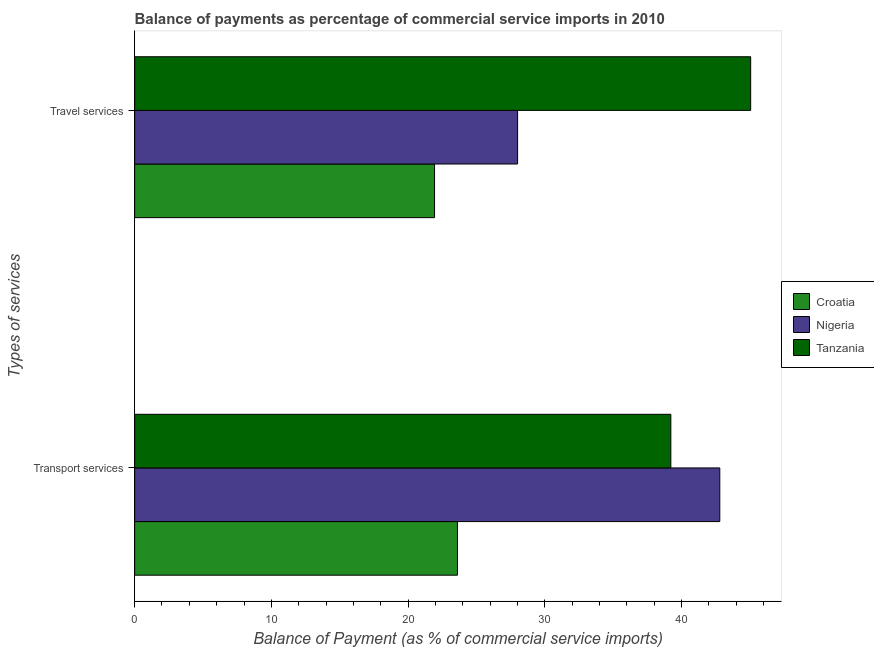How many different coloured bars are there?
Keep it short and to the point. 3. How many groups of bars are there?
Your answer should be very brief. 2. Are the number of bars per tick equal to the number of legend labels?
Your answer should be compact. Yes. How many bars are there on the 1st tick from the top?
Provide a short and direct response. 3. What is the label of the 2nd group of bars from the top?
Ensure brevity in your answer.  Transport services. What is the balance of payments of travel services in Nigeria?
Your answer should be very brief. 28.02. Across all countries, what is the maximum balance of payments of travel services?
Your answer should be compact. 45.07. Across all countries, what is the minimum balance of payments of travel services?
Your answer should be very brief. 21.94. In which country was the balance of payments of travel services maximum?
Your answer should be compact. Tanzania. In which country was the balance of payments of transport services minimum?
Offer a terse response. Croatia. What is the total balance of payments of travel services in the graph?
Your answer should be compact. 95.03. What is the difference between the balance of payments of travel services in Nigeria and that in Croatia?
Ensure brevity in your answer.  6.08. What is the difference between the balance of payments of transport services in Croatia and the balance of payments of travel services in Tanzania?
Provide a short and direct response. -21.45. What is the average balance of payments of travel services per country?
Provide a short and direct response. 31.68. What is the difference between the balance of payments of transport services and balance of payments of travel services in Nigeria?
Offer a very short reply. 14.79. What is the ratio of the balance of payments of travel services in Croatia to that in Tanzania?
Offer a terse response. 0.49. What does the 3rd bar from the top in Transport services represents?
Give a very brief answer. Croatia. What does the 3rd bar from the bottom in Travel services represents?
Give a very brief answer. Tanzania. Are all the bars in the graph horizontal?
Your answer should be compact. Yes. How many countries are there in the graph?
Provide a succinct answer. 3. Does the graph contain grids?
Your answer should be compact. No. How are the legend labels stacked?
Keep it short and to the point. Vertical. What is the title of the graph?
Provide a short and direct response. Balance of payments as percentage of commercial service imports in 2010. Does "Iceland" appear as one of the legend labels in the graph?
Your answer should be very brief. No. What is the label or title of the X-axis?
Your response must be concise. Balance of Payment (as % of commercial service imports). What is the label or title of the Y-axis?
Offer a very short reply. Types of services. What is the Balance of Payment (as % of commercial service imports) of Croatia in Transport services?
Provide a short and direct response. 23.62. What is the Balance of Payment (as % of commercial service imports) in Nigeria in Transport services?
Offer a terse response. 42.81. What is the Balance of Payment (as % of commercial service imports) of Tanzania in Transport services?
Keep it short and to the point. 39.23. What is the Balance of Payment (as % of commercial service imports) in Croatia in Travel services?
Offer a very short reply. 21.94. What is the Balance of Payment (as % of commercial service imports) of Nigeria in Travel services?
Offer a very short reply. 28.02. What is the Balance of Payment (as % of commercial service imports) in Tanzania in Travel services?
Offer a terse response. 45.07. Across all Types of services, what is the maximum Balance of Payment (as % of commercial service imports) in Croatia?
Give a very brief answer. 23.62. Across all Types of services, what is the maximum Balance of Payment (as % of commercial service imports) of Nigeria?
Ensure brevity in your answer.  42.81. Across all Types of services, what is the maximum Balance of Payment (as % of commercial service imports) in Tanzania?
Ensure brevity in your answer.  45.07. Across all Types of services, what is the minimum Balance of Payment (as % of commercial service imports) of Croatia?
Your answer should be very brief. 21.94. Across all Types of services, what is the minimum Balance of Payment (as % of commercial service imports) in Nigeria?
Make the answer very short. 28.02. Across all Types of services, what is the minimum Balance of Payment (as % of commercial service imports) of Tanzania?
Offer a very short reply. 39.23. What is the total Balance of Payment (as % of commercial service imports) of Croatia in the graph?
Provide a short and direct response. 45.56. What is the total Balance of Payment (as % of commercial service imports) of Nigeria in the graph?
Give a very brief answer. 70.83. What is the total Balance of Payment (as % of commercial service imports) of Tanzania in the graph?
Your answer should be compact. 84.3. What is the difference between the Balance of Payment (as % of commercial service imports) of Croatia in Transport services and that in Travel services?
Give a very brief answer. 1.68. What is the difference between the Balance of Payment (as % of commercial service imports) in Nigeria in Transport services and that in Travel services?
Keep it short and to the point. 14.79. What is the difference between the Balance of Payment (as % of commercial service imports) in Tanzania in Transport services and that in Travel services?
Keep it short and to the point. -5.84. What is the difference between the Balance of Payment (as % of commercial service imports) in Croatia in Transport services and the Balance of Payment (as % of commercial service imports) in Nigeria in Travel services?
Your answer should be very brief. -4.4. What is the difference between the Balance of Payment (as % of commercial service imports) of Croatia in Transport services and the Balance of Payment (as % of commercial service imports) of Tanzania in Travel services?
Your answer should be very brief. -21.45. What is the difference between the Balance of Payment (as % of commercial service imports) of Nigeria in Transport services and the Balance of Payment (as % of commercial service imports) of Tanzania in Travel services?
Your answer should be compact. -2.26. What is the average Balance of Payment (as % of commercial service imports) of Croatia per Types of services?
Give a very brief answer. 22.78. What is the average Balance of Payment (as % of commercial service imports) in Nigeria per Types of services?
Provide a succinct answer. 35.41. What is the average Balance of Payment (as % of commercial service imports) of Tanzania per Types of services?
Ensure brevity in your answer.  42.15. What is the difference between the Balance of Payment (as % of commercial service imports) in Croatia and Balance of Payment (as % of commercial service imports) in Nigeria in Transport services?
Your answer should be very brief. -19.19. What is the difference between the Balance of Payment (as % of commercial service imports) in Croatia and Balance of Payment (as % of commercial service imports) in Tanzania in Transport services?
Your response must be concise. -15.61. What is the difference between the Balance of Payment (as % of commercial service imports) of Nigeria and Balance of Payment (as % of commercial service imports) of Tanzania in Transport services?
Your answer should be compact. 3.58. What is the difference between the Balance of Payment (as % of commercial service imports) in Croatia and Balance of Payment (as % of commercial service imports) in Nigeria in Travel services?
Your answer should be very brief. -6.08. What is the difference between the Balance of Payment (as % of commercial service imports) of Croatia and Balance of Payment (as % of commercial service imports) of Tanzania in Travel services?
Give a very brief answer. -23.13. What is the difference between the Balance of Payment (as % of commercial service imports) in Nigeria and Balance of Payment (as % of commercial service imports) in Tanzania in Travel services?
Make the answer very short. -17.05. What is the ratio of the Balance of Payment (as % of commercial service imports) of Croatia in Transport services to that in Travel services?
Your answer should be very brief. 1.08. What is the ratio of the Balance of Payment (as % of commercial service imports) in Nigeria in Transport services to that in Travel services?
Ensure brevity in your answer.  1.53. What is the ratio of the Balance of Payment (as % of commercial service imports) in Tanzania in Transport services to that in Travel services?
Offer a terse response. 0.87. What is the difference between the highest and the second highest Balance of Payment (as % of commercial service imports) of Croatia?
Provide a short and direct response. 1.68. What is the difference between the highest and the second highest Balance of Payment (as % of commercial service imports) of Nigeria?
Offer a very short reply. 14.79. What is the difference between the highest and the second highest Balance of Payment (as % of commercial service imports) of Tanzania?
Make the answer very short. 5.84. What is the difference between the highest and the lowest Balance of Payment (as % of commercial service imports) of Croatia?
Your answer should be compact. 1.68. What is the difference between the highest and the lowest Balance of Payment (as % of commercial service imports) in Nigeria?
Make the answer very short. 14.79. What is the difference between the highest and the lowest Balance of Payment (as % of commercial service imports) of Tanzania?
Offer a terse response. 5.84. 